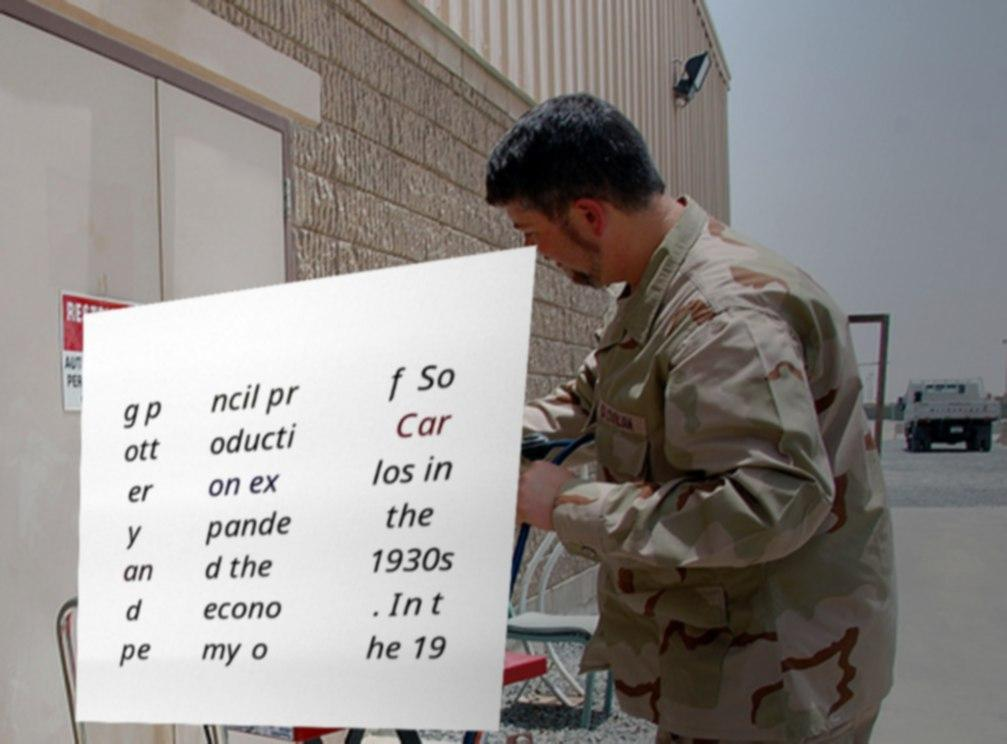I need the written content from this picture converted into text. Can you do that? g p ott er y an d pe ncil pr oducti on ex pande d the econo my o f So Car los in the 1930s . In t he 19 